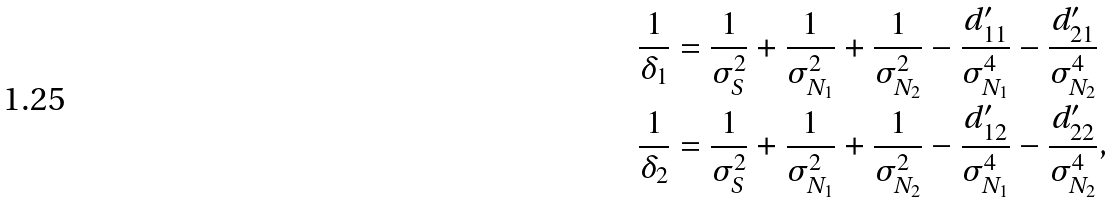Convert formula to latex. <formula><loc_0><loc_0><loc_500><loc_500>\frac { 1 } { \delta _ { 1 } } & = \frac { 1 } { \sigma _ { S } ^ { 2 } } + \frac { 1 } { \sigma _ { N _ { 1 } } ^ { 2 } } + \frac { 1 } { \sigma _ { N _ { 2 } } ^ { 2 } } - \frac { d _ { 1 1 } ^ { \prime } } { \sigma _ { N _ { 1 } } ^ { 4 } } - \frac { d _ { 2 1 } ^ { \prime } } { \sigma _ { N _ { 2 } } ^ { 4 } } \\ \frac { 1 } { \delta _ { 2 } } & = \frac { 1 } { \sigma _ { S } ^ { 2 } } + \frac { 1 } { \sigma _ { N _ { 1 } } ^ { 2 } } + \frac { 1 } { \sigma _ { N _ { 2 } } ^ { 2 } } - \frac { d _ { 1 2 } ^ { \prime } } { \sigma _ { N _ { 1 } } ^ { 4 } } - \frac { d _ { 2 2 } ^ { \prime } } { \sigma _ { N _ { 2 } } ^ { 4 } } ,</formula> 